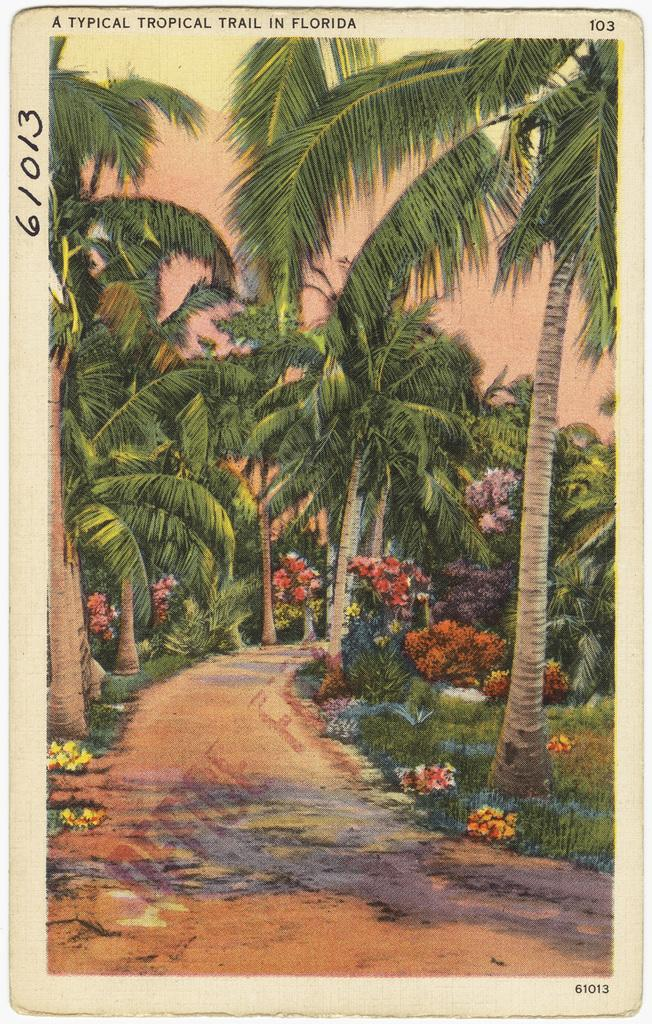What is depicted on the paper in the image? There is art on a paper in the image. What type of cars can be seen in the image? There are no cars present in the image; it only features art on a paper. What type of steel is used to create the art in the image? The image does not provide information about the materials used to create the art, so it cannot be determined from the image. 